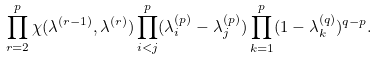<formula> <loc_0><loc_0><loc_500><loc_500>\prod _ { r = 2 } ^ { p } \chi ( \lambda ^ { ( r - 1 ) } , \lambda ^ { ( r ) } ) \prod _ { i < j } ^ { p } ( \lambda _ { i } ^ { ( p ) } - \lambda _ { j } ^ { ( p ) } ) \prod _ { k = 1 } ^ { p } ( 1 - \lambda _ { k } ^ { ( q ) } ) ^ { q - p } .</formula> 